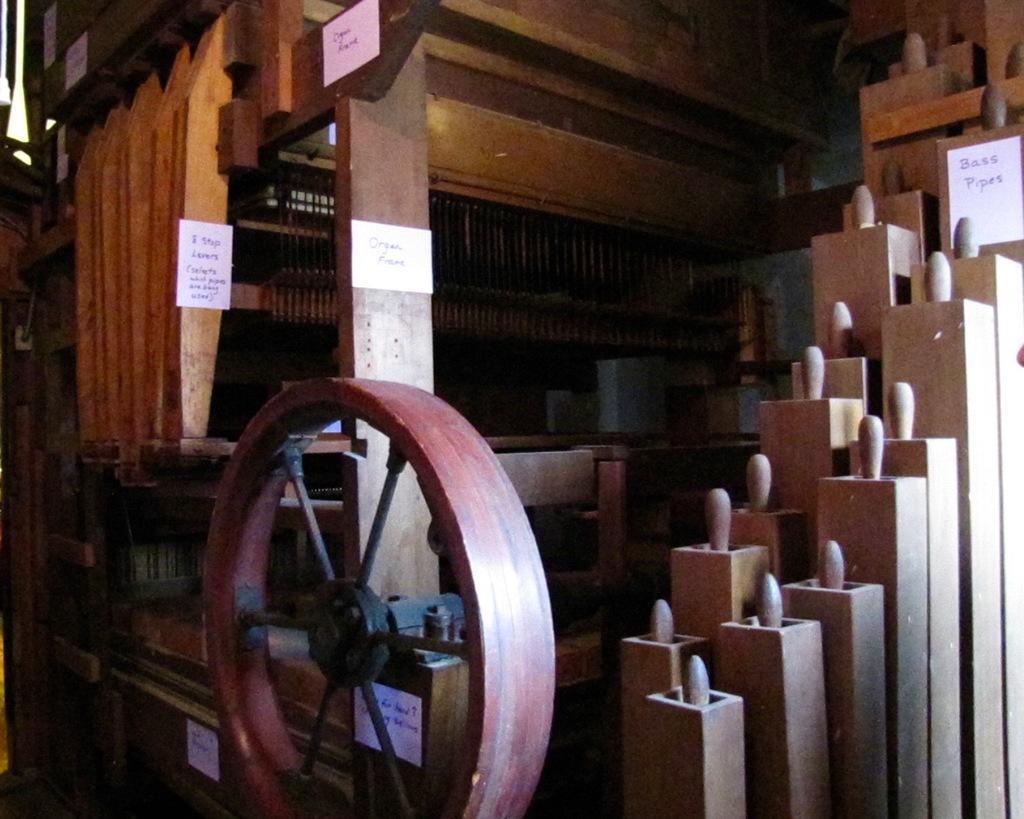Can you describe this image briefly? In this image there is an wooden architecture with papers attached to it, on the papers there is some text. 